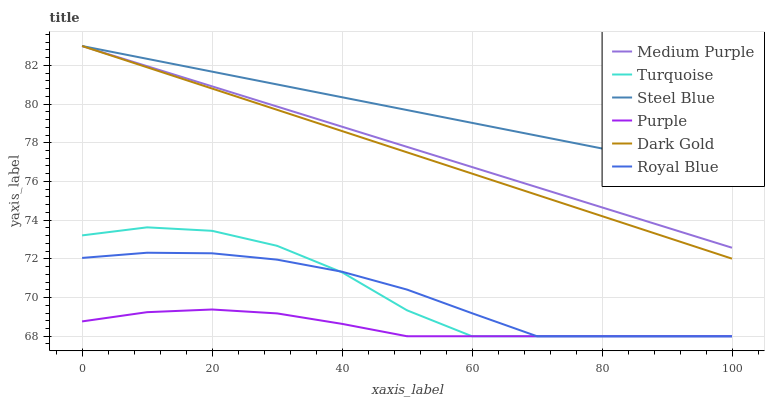Does Purple have the minimum area under the curve?
Answer yes or no. Yes. Does Dark Gold have the minimum area under the curve?
Answer yes or no. No. Does Dark Gold have the maximum area under the curve?
Answer yes or no. No. Is Dark Gold the smoothest?
Answer yes or no. No. Is Dark Gold the roughest?
Answer yes or no. No. Does Dark Gold have the lowest value?
Answer yes or no. No. Does Purple have the highest value?
Answer yes or no. No. Is Royal Blue less than Steel Blue?
Answer yes or no. Yes. Is Dark Gold greater than Purple?
Answer yes or no. Yes. Does Royal Blue intersect Steel Blue?
Answer yes or no. No. 